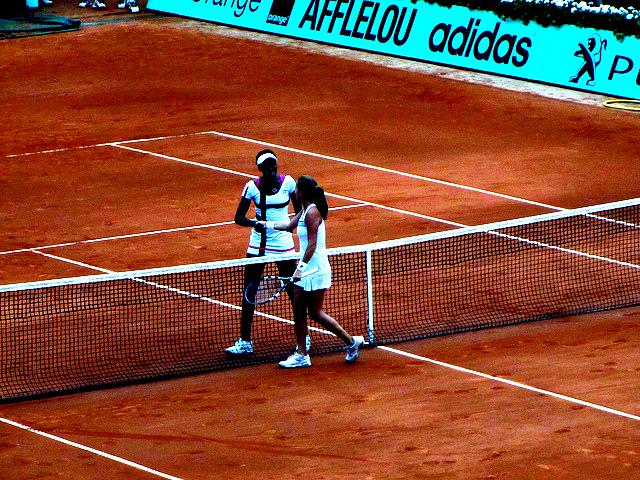Can you describe what's happening in this image? The image captures two tennis players shaking hands over a tennis net, suggesting they have likely just finished a match or are greeting each other before it begins. The setting appears to be a professional clay court, recognizable by the reddish-brown surface. 